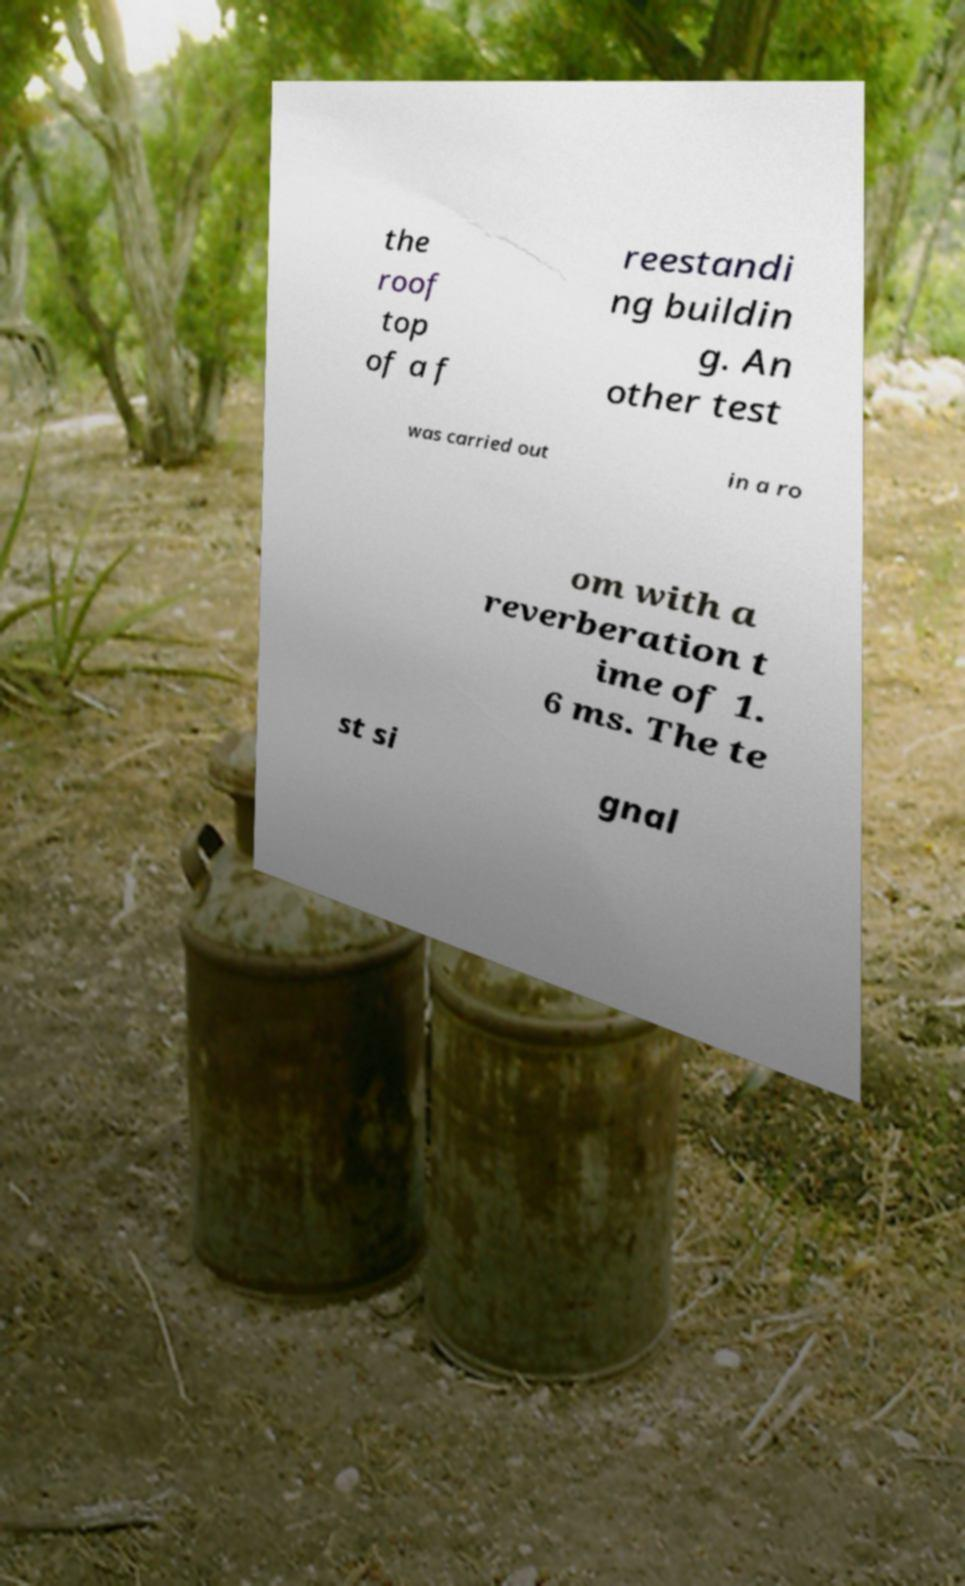Can you accurately transcribe the text from the provided image for me? the roof top of a f reestandi ng buildin g. An other test was carried out in a ro om with a reverberation t ime of 1. 6 ms. The te st si gnal 